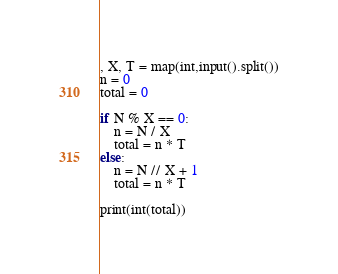Convert code to text. <code><loc_0><loc_0><loc_500><loc_500><_Python_>, X, T = map(int,input().split())
n = 0
total = 0

if N % X == 0:
    n = N / X
    total = n * T
else:
    n = N // X + 1
    total = n * T

print(int(total))</code> 